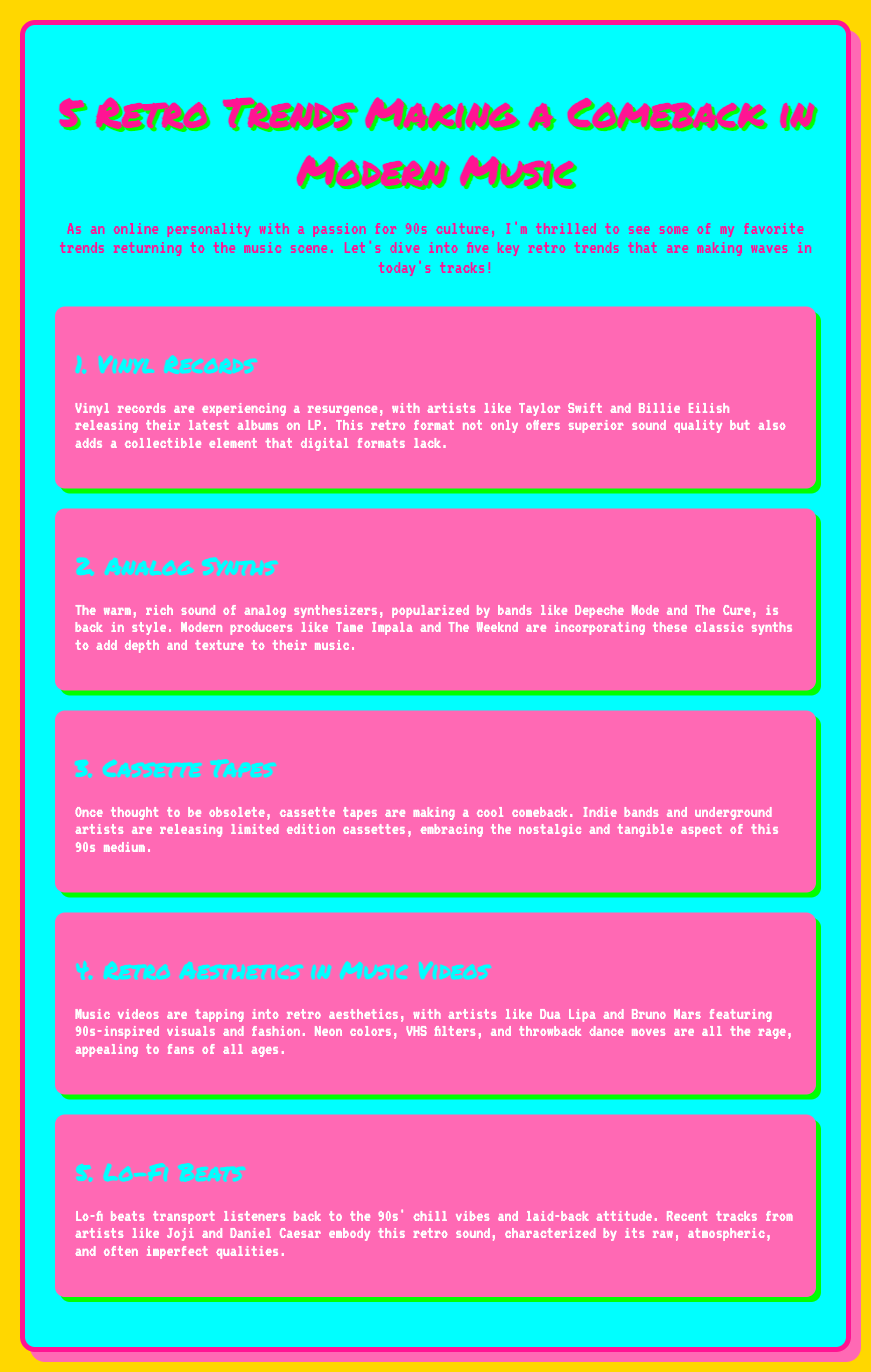What are vinyl records experiencing? The document states that vinyl records are experiencing a resurgence.
Answer: Resurgence Which artists are mentioned in relation to vinyl records? The document lists Taylor Swift and Billie Eilish as artists releasing albums on LP.
Answer: Taylor Swift and Billie Eilish What retro sound is associated with analog synths? The document describes the sound of analog synthesizers as warm and rich.
Answer: Warm and rich Which modern producers are noted for using analog synths? Tame Impala and The Weeknd are named as modern producers incorporating analog synths.
Answer: Tame Impala and The Weeknd What medium is making a comeback alongside cassette tapes? The document refers to limited edition cassettes as a medium that indie bands and underground artists are embracing.
Answer: Cassettes What aesthetic style is emphasized in modern music videos? Retro aesthetics are highlighted in the music videos, particularly with 90s-inspired visuals.
Answer: Retro aesthetics Which artists are mentioned regarding retro aesthetics in music videos? Dua Lipa and Bruno Mars are mentioned for featuring 90s-inspired visuals in their videos.
Answer: Dua Lipa and Bruno Mars What type of beats reflect the 90s vibe according to the document? Lo-fi beats are identified as embodying the chill vibes of the 90s.
Answer: Lo-fi beats Who are two artists exemplifying the lo-fi beats trend? Joji and Daniel Caesar are noted for their tracks embodying retro lo-fi sound qualities.
Answer: Joji and Daniel Caesar 